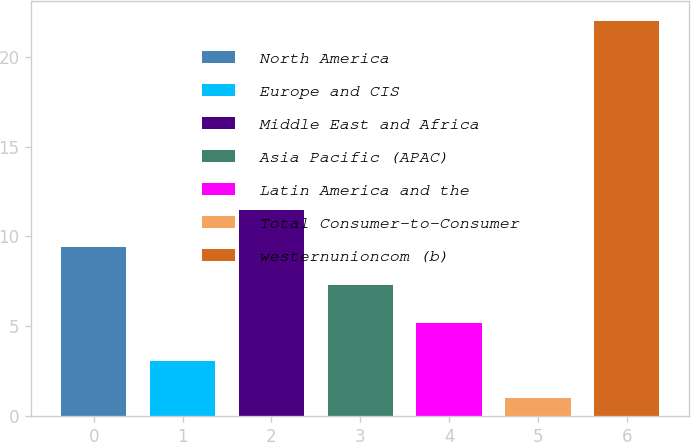Convert chart to OTSL. <chart><loc_0><loc_0><loc_500><loc_500><bar_chart><fcel>North America<fcel>Europe and CIS<fcel>Middle East and Africa<fcel>Asia Pacific (APAC)<fcel>Latin America and the<fcel>Total Consumer-to-Consumer<fcel>westernunioncom (b)<nl><fcel>9.4<fcel>3.1<fcel>11.5<fcel>7.3<fcel>5.2<fcel>1<fcel>22<nl></chart> 